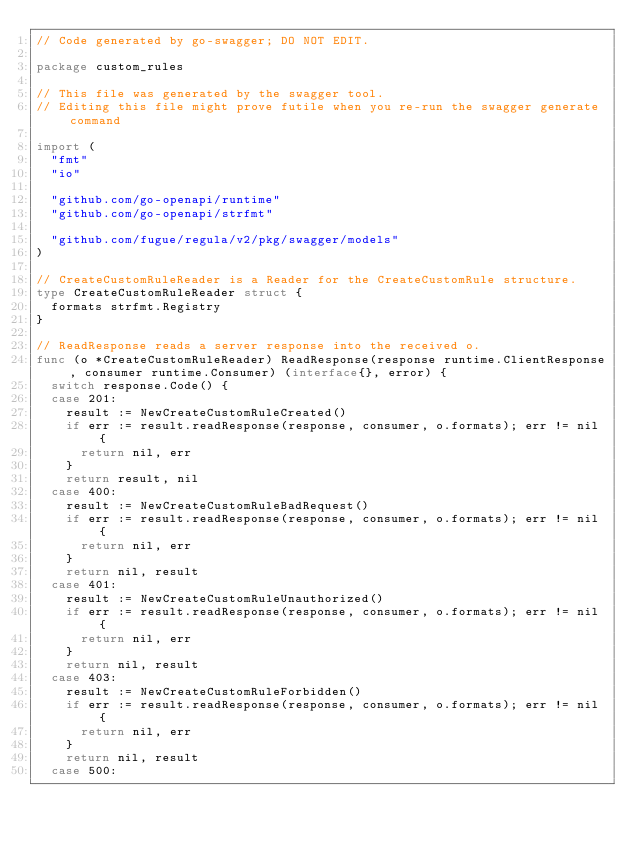<code> <loc_0><loc_0><loc_500><loc_500><_Go_>// Code generated by go-swagger; DO NOT EDIT.

package custom_rules

// This file was generated by the swagger tool.
// Editing this file might prove futile when you re-run the swagger generate command

import (
	"fmt"
	"io"

	"github.com/go-openapi/runtime"
	"github.com/go-openapi/strfmt"

	"github.com/fugue/regula/v2/pkg/swagger/models"
)

// CreateCustomRuleReader is a Reader for the CreateCustomRule structure.
type CreateCustomRuleReader struct {
	formats strfmt.Registry
}

// ReadResponse reads a server response into the received o.
func (o *CreateCustomRuleReader) ReadResponse(response runtime.ClientResponse, consumer runtime.Consumer) (interface{}, error) {
	switch response.Code() {
	case 201:
		result := NewCreateCustomRuleCreated()
		if err := result.readResponse(response, consumer, o.formats); err != nil {
			return nil, err
		}
		return result, nil
	case 400:
		result := NewCreateCustomRuleBadRequest()
		if err := result.readResponse(response, consumer, o.formats); err != nil {
			return nil, err
		}
		return nil, result
	case 401:
		result := NewCreateCustomRuleUnauthorized()
		if err := result.readResponse(response, consumer, o.formats); err != nil {
			return nil, err
		}
		return nil, result
	case 403:
		result := NewCreateCustomRuleForbidden()
		if err := result.readResponse(response, consumer, o.formats); err != nil {
			return nil, err
		}
		return nil, result
	case 500:</code> 